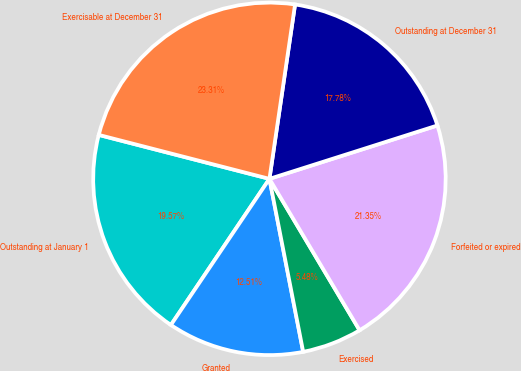Convert chart. <chart><loc_0><loc_0><loc_500><loc_500><pie_chart><fcel>Outstanding at January 1<fcel>Granted<fcel>Exercised<fcel>Forfeited or expired<fcel>Outstanding at December 31<fcel>Exercisable at December 31<nl><fcel>19.57%<fcel>12.51%<fcel>5.48%<fcel>21.35%<fcel>17.78%<fcel>23.31%<nl></chart> 